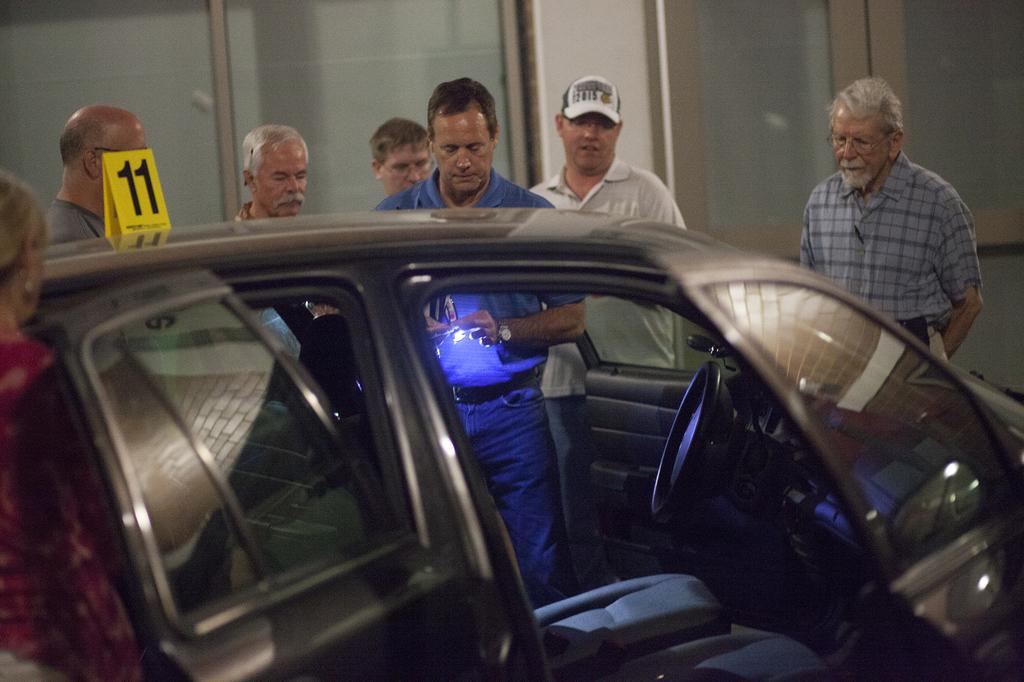What is the main subject in the center of the image? There is a car in the center of the image. What can be seen in the background of the image? There are persons visible in the background, as well as windows. What type of leather is covering the beast in the image? There is no beast present in the image, and therefore no leather covering it. 